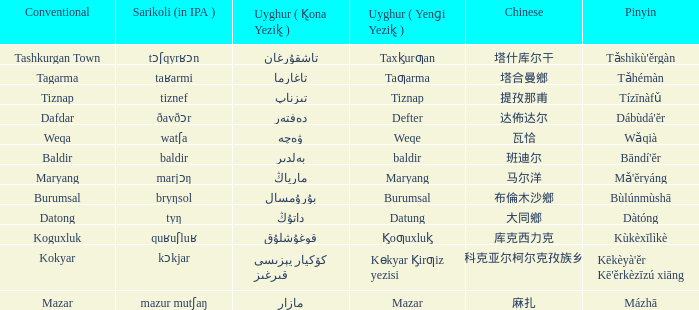Name the conventional for defter Dafdar. 